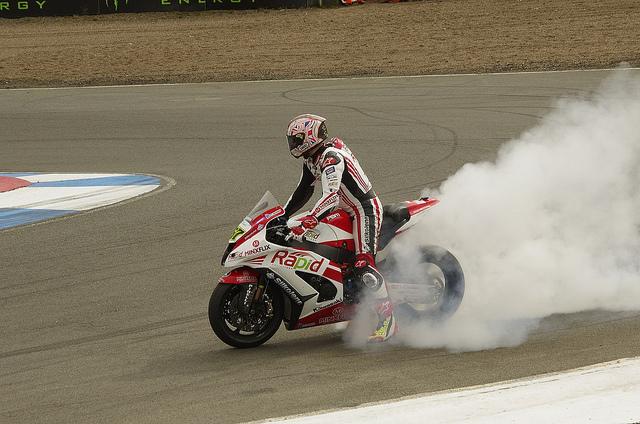What is the smoke coming from?
Answer briefly. Motorcycle. Is this a bike removing smoke?
Be succinct. No. What is on the man's head?
Give a very brief answer. Helmet. What color is the bike?
Quick response, please. Red and white. What track was this man on?
Short answer required. Race track. 